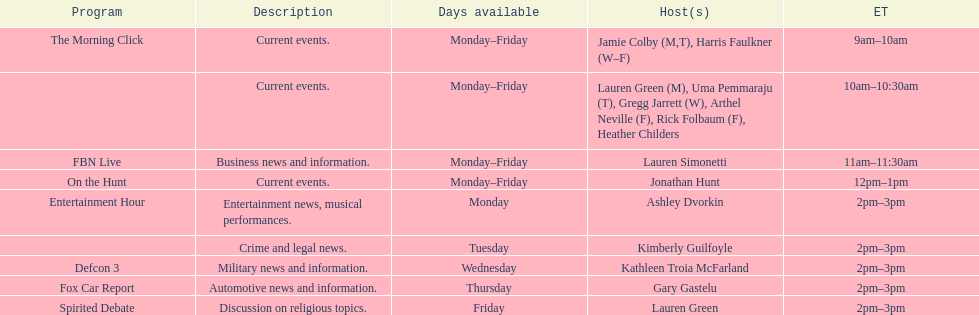How many days is fbn live available each week? 5. 